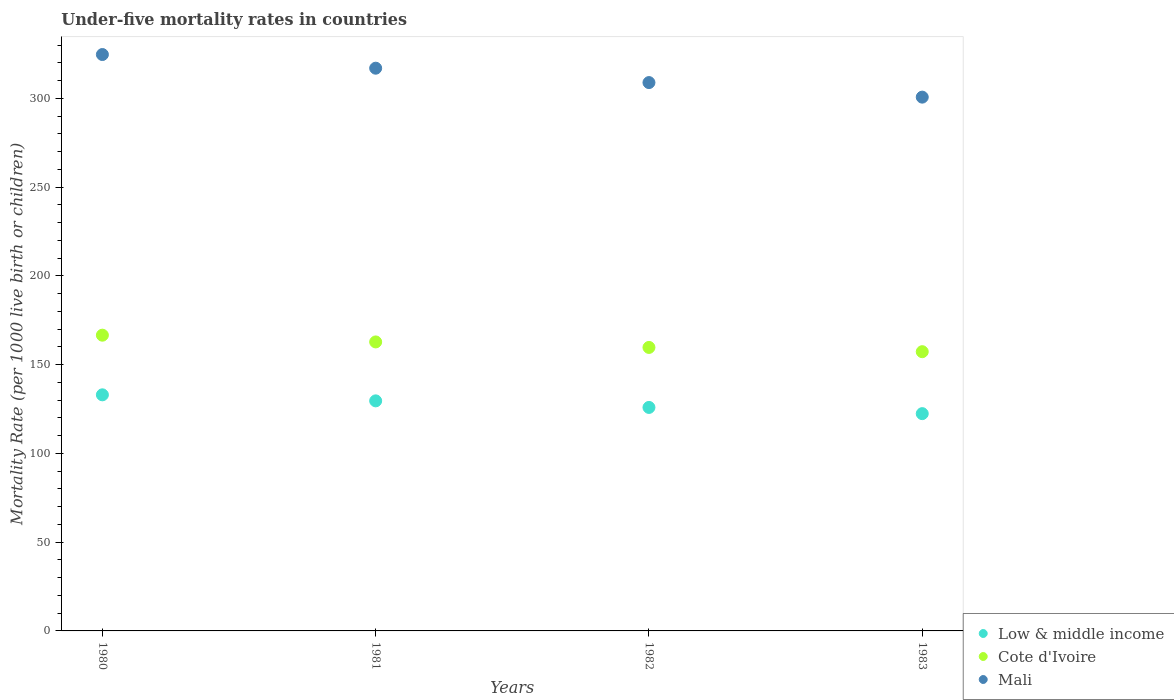How many different coloured dotlines are there?
Give a very brief answer. 3. Is the number of dotlines equal to the number of legend labels?
Offer a terse response. Yes. What is the under-five mortality rate in Mali in 1983?
Keep it short and to the point. 300.7. Across all years, what is the maximum under-five mortality rate in Mali?
Your answer should be very brief. 324.7. Across all years, what is the minimum under-five mortality rate in Low & middle income?
Your response must be concise. 122.4. What is the total under-five mortality rate in Cote d'Ivoire in the graph?
Offer a terse response. 646.4. What is the difference between the under-five mortality rate in Cote d'Ivoire in 1981 and that in 1982?
Offer a very short reply. 3.1. What is the difference between the under-five mortality rate in Mali in 1983 and the under-five mortality rate in Cote d'Ivoire in 1980?
Provide a short and direct response. 134.1. What is the average under-five mortality rate in Low & middle income per year?
Make the answer very short. 127.72. In the year 1981, what is the difference between the under-five mortality rate in Low & middle income and under-five mortality rate in Cote d'Ivoire?
Your answer should be very brief. -33.2. In how many years, is the under-five mortality rate in Cote d'Ivoire greater than 60?
Provide a short and direct response. 4. What is the ratio of the under-five mortality rate in Cote d'Ivoire in 1982 to that in 1983?
Your answer should be compact. 1.02. Is the under-five mortality rate in Mali in 1980 less than that in 1981?
Keep it short and to the point. No. What is the difference between the highest and the second highest under-five mortality rate in Mali?
Your answer should be very brief. 7.7. What is the difference between the highest and the lowest under-five mortality rate in Low & middle income?
Ensure brevity in your answer.  10.6. In how many years, is the under-five mortality rate in Low & middle income greater than the average under-five mortality rate in Low & middle income taken over all years?
Give a very brief answer. 2. Is it the case that in every year, the sum of the under-five mortality rate in Low & middle income and under-five mortality rate in Mali  is greater than the under-five mortality rate in Cote d'Ivoire?
Ensure brevity in your answer.  Yes. Is the under-five mortality rate in Low & middle income strictly less than the under-five mortality rate in Cote d'Ivoire over the years?
Offer a terse response. Yes. How many dotlines are there?
Your answer should be very brief. 3. What is the difference between two consecutive major ticks on the Y-axis?
Your answer should be very brief. 50. Are the values on the major ticks of Y-axis written in scientific E-notation?
Ensure brevity in your answer.  No. Does the graph contain any zero values?
Provide a succinct answer. No. How are the legend labels stacked?
Your response must be concise. Vertical. What is the title of the graph?
Keep it short and to the point. Under-five mortality rates in countries. What is the label or title of the Y-axis?
Your answer should be compact. Mortality Rate (per 1000 live birth or children). What is the Mortality Rate (per 1000 live birth or children) of Low & middle income in 1980?
Offer a terse response. 133. What is the Mortality Rate (per 1000 live birth or children) of Cote d'Ivoire in 1980?
Offer a very short reply. 166.6. What is the Mortality Rate (per 1000 live birth or children) of Mali in 1980?
Your answer should be very brief. 324.7. What is the Mortality Rate (per 1000 live birth or children) of Low & middle income in 1981?
Your response must be concise. 129.6. What is the Mortality Rate (per 1000 live birth or children) in Cote d'Ivoire in 1981?
Make the answer very short. 162.8. What is the Mortality Rate (per 1000 live birth or children) in Mali in 1981?
Keep it short and to the point. 317. What is the Mortality Rate (per 1000 live birth or children) in Low & middle income in 1982?
Give a very brief answer. 125.9. What is the Mortality Rate (per 1000 live birth or children) in Cote d'Ivoire in 1982?
Keep it short and to the point. 159.7. What is the Mortality Rate (per 1000 live birth or children) in Mali in 1982?
Your answer should be very brief. 308.9. What is the Mortality Rate (per 1000 live birth or children) of Low & middle income in 1983?
Offer a very short reply. 122.4. What is the Mortality Rate (per 1000 live birth or children) of Cote d'Ivoire in 1983?
Ensure brevity in your answer.  157.3. What is the Mortality Rate (per 1000 live birth or children) in Mali in 1983?
Offer a terse response. 300.7. Across all years, what is the maximum Mortality Rate (per 1000 live birth or children) of Low & middle income?
Keep it short and to the point. 133. Across all years, what is the maximum Mortality Rate (per 1000 live birth or children) of Cote d'Ivoire?
Offer a terse response. 166.6. Across all years, what is the maximum Mortality Rate (per 1000 live birth or children) in Mali?
Your answer should be compact. 324.7. Across all years, what is the minimum Mortality Rate (per 1000 live birth or children) in Low & middle income?
Offer a very short reply. 122.4. Across all years, what is the minimum Mortality Rate (per 1000 live birth or children) in Cote d'Ivoire?
Give a very brief answer. 157.3. Across all years, what is the minimum Mortality Rate (per 1000 live birth or children) of Mali?
Provide a succinct answer. 300.7. What is the total Mortality Rate (per 1000 live birth or children) of Low & middle income in the graph?
Give a very brief answer. 510.9. What is the total Mortality Rate (per 1000 live birth or children) in Cote d'Ivoire in the graph?
Your answer should be compact. 646.4. What is the total Mortality Rate (per 1000 live birth or children) in Mali in the graph?
Your answer should be compact. 1251.3. What is the difference between the Mortality Rate (per 1000 live birth or children) of Low & middle income in 1980 and that in 1981?
Offer a very short reply. 3.4. What is the difference between the Mortality Rate (per 1000 live birth or children) in Low & middle income in 1980 and that in 1982?
Keep it short and to the point. 7.1. What is the difference between the Mortality Rate (per 1000 live birth or children) of Cote d'Ivoire in 1980 and that in 1982?
Your answer should be compact. 6.9. What is the difference between the Mortality Rate (per 1000 live birth or children) of Mali in 1980 and that in 1982?
Ensure brevity in your answer.  15.8. What is the difference between the Mortality Rate (per 1000 live birth or children) in Cote d'Ivoire in 1980 and that in 1983?
Provide a succinct answer. 9.3. What is the difference between the Mortality Rate (per 1000 live birth or children) in Mali in 1980 and that in 1983?
Give a very brief answer. 24. What is the difference between the Mortality Rate (per 1000 live birth or children) in Cote d'Ivoire in 1981 and that in 1982?
Provide a succinct answer. 3.1. What is the difference between the Mortality Rate (per 1000 live birth or children) of Cote d'Ivoire in 1981 and that in 1983?
Ensure brevity in your answer.  5.5. What is the difference between the Mortality Rate (per 1000 live birth or children) in Low & middle income in 1982 and that in 1983?
Your response must be concise. 3.5. What is the difference between the Mortality Rate (per 1000 live birth or children) of Cote d'Ivoire in 1982 and that in 1983?
Keep it short and to the point. 2.4. What is the difference between the Mortality Rate (per 1000 live birth or children) of Low & middle income in 1980 and the Mortality Rate (per 1000 live birth or children) of Cote d'Ivoire in 1981?
Give a very brief answer. -29.8. What is the difference between the Mortality Rate (per 1000 live birth or children) in Low & middle income in 1980 and the Mortality Rate (per 1000 live birth or children) in Mali in 1981?
Provide a succinct answer. -184. What is the difference between the Mortality Rate (per 1000 live birth or children) in Cote d'Ivoire in 1980 and the Mortality Rate (per 1000 live birth or children) in Mali in 1981?
Provide a short and direct response. -150.4. What is the difference between the Mortality Rate (per 1000 live birth or children) of Low & middle income in 1980 and the Mortality Rate (per 1000 live birth or children) of Cote d'Ivoire in 1982?
Ensure brevity in your answer.  -26.7. What is the difference between the Mortality Rate (per 1000 live birth or children) of Low & middle income in 1980 and the Mortality Rate (per 1000 live birth or children) of Mali in 1982?
Offer a very short reply. -175.9. What is the difference between the Mortality Rate (per 1000 live birth or children) of Cote d'Ivoire in 1980 and the Mortality Rate (per 1000 live birth or children) of Mali in 1982?
Keep it short and to the point. -142.3. What is the difference between the Mortality Rate (per 1000 live birth or children) in Low & middle income in 1980 and the Mortality Rate (per 1000 live birth or children) in Cote d'Ivoire in 1983?
Your answer should be compact. -24.3. What is the difference between the Mortality Rate (per 1000 live birth or children) in Low & middle income in 1980 and the Mortality Rate (per 1000 live birth or children) in Mali in 1983?
Your response must be concise. -167.7. What is the difference between the Mortality Rate (per 1000 live birth or children) of Cote d'Ivoire in 1980 and the Mortality Rate (per 1000 live birth or children) of Mali in 1983?
Give a very brief answer. -134.1. What is the difference between the Mortality Rate (per 1000 live birth or children) of Low & middle income in 1981 and the Mortality Rate (per 1000 live birth or children) of Cote d'Ivoire in 1982?
Offer a very short reply. -30.1. What is the difference between the Mortality Rate (per 1000 live birth or children) in Low & middle income in 1981 and the Mortality Rate (per 1000 live birth or children) in Mali in 1982?
Offer a very short reply. -179.3. What is the difference between the Mortality Rate (per 1000 live birth or children) in Cote d'Ivoire in 1981 and the Mortality Rate (per 1000 live birth or children) in Mali in 1982?
Offer a very short reply. -146.1. What is the difference between the Mortality Rate (per 1000 live birth or children) in Low & middle income in 1981 and the Mortality Rate (per 1000 live birth or children) in Cote d'Ivoire in 1983?
Provide a succinct answer. -27.7. What is the difference between the Mortality Rate (per 1000 live birth or children) of Low & middle income in 1981 and the Mortality Rate (per 1000 live birth or children) of Mali in 1983?
Provide a short and direct response. -171.1. What is the difference between the Mortality Rate (per 1000 live birth or children) in Cote d'Ivoire in 1981 and the Mortality Rate (per 1000 live birth or children) in Mali in 1983?
Offer a terse response. -137.9. What is the difference between the Mortality Rate (per 1000 live birth or children) in Low & middle income in 1982 and the Mortality Rate (per 1000 live birth or children) in Cote d'Ivoire in 1983?
Make the answer very short. -31.4. What is the difference between the Mortality Rate (per 1000 live birth or children) in Low & middle income in 1982 and the Mortality Rate (per 1000 live birth or children) in Mali in 1983?
Your answer should be very brief. -174.8. What is the difference between the Mortality Rate (per 1000 live birth or children) in Cote d'Ivoire in 1982 and the Mortality Rate (per 1000 live birth or children) in Mali in 1983?
Give a very brief answer. -141. What is the average Mortality Rate (per 1000 live birth or children) of Low & middle income per year?
Keep it short and to the point. 127.72. What is the average Mortality Rate (per 1000 live birth or children) in Cote d'Ivoire per year?
Your answer should be compact. 161.6. What is the average Mortality Rate (per 1000 live birth or children) in Mali per year?
Give a very brief answer. 312.82. In the year 1980, what is the difference between the Mortality Rate (per 1000 live birth or children) of Low & middle income and Mortality Rate (per 1000 live birth or children) of Cote d'Ivoire?
Make the answer very short. -33.6. In the year 1980, what is the difference between the Mortality Rate (per 1000 live birth or children) of Low & middle income and Mortality Rate (per 1000 live birth or children) of Mali?
Provide a short and direct response. -191.7. In the year 1980, what is the difference between the Mortality Rate (per 1000 live birth or children) in Cote d'Ivoire and Mortality Rate (per 1000 live birth or children) in Mali?
Offer a very short reply. -158.1. In the year 1981, what is the difference between the Mortality Rate (per 1000 live birth or children) in Low & middle income and Mortality Rate (per 1000 live birth or children) in Cote d'Ivoire?
Offer a very short reply. -33.2. In the year 1981, what is the difference between the Mortality Rate (per 1000 live birth or children) of Low & middle income and Mortality Rate (per 1000 live birth or children) of Mali?
Keep it short and to the point. -187.4. In the year 1981, what is the difference between the Mortality Rate (per 1000 live birth or children) of Cote d'Ivoire and Mortality Rate (per 1000 live birth or children) of Mali?
Offer a very short reply. -154.2. In the year 1982, what is the difference between the Mortality Rate (per 1000 live birth or children) in Low & middle income and Mortality Rate (per 1000 live birth or children) in Cote d'Ivoire?
Give a very brief answer. -33.8. In the year 1982, what is the difference between the Mortality Rate (per 1000 live birth or children) in Low & middle income and Mortality Rate (per 1000 live birth or children) in Mali?
Your answer should be very brief. -183. In the year 1982, what is the difference between the Mortality Rate (per 1000 live birth or children) of Cote d'Ivoire and Mortality Rate (per 1000 live birth or children) of Mali?
Ensure brevity in your answer.  -149.2. In the year 1983, what is the difference between the Mortality Rate (per 1000 live birth or children) of Low & middle income and Mortality Rate (per 1000 live birth or children) of Cote d'Ivoire?
Provide a short and direct response. -34.9. In the year 1983, what is the difference between the Mortality Rate (per 1000 live birth or children) of Low & middle income and Mortality Rate (per 1000 live birth or children) of Mali?
Offer a very short reply. -178.3. In the year 1983, what is the difference between the Mortality Rate (per 1000 live birth or children) of Cote d'Ivoire and Mortality Rate (per 1000 live birth or children) of Mali?
Keep it short and to the point. -143.4. What is the ratio of the Mortality Rate (per 1000 live birth or children) of Low & middle income in 1980 to that in 1981?
Your response must be concise. 1.03. What is the ratio of the Mortality Rate (per 1000 live birth or children) in Cote d'Ivoire in 1980 to that in 1981?
Your response must be concise. 1.02. What is the ratio of the Mortality Rate (per 1000 live birth or children) of Mali in 1980 to that in 1981?
Your answer should be compact. 1.02. What is the ratio of the Mortality Rate (per 1000 live birth or children) of Low & middle income in 1980 to that in 1982?
Make the answer very short. 1.06. What is the ratio of the Mortality Rate (per 1000 live birth or children) in Cote d'Ivoire in 1980 to that in 1982?
Provide a succinct answer. 1.04. What is the ratio of the Mortality Rate (per 1000 live birth or children) in Mali in 1980 to that in 1982?
Your answer should be very brief. 1.05. What is the ratio of the Mortality Rate (per 1000 live birth or children) in Low & middle income in 1980 to that in 1983?
Provide a succinct answer. 1.09. What is the ratio of the Mortality Rate (per 1000 live birth or children) in Cote d'Ivoire in 1980 to that in 1983?
Offer a terse response. 1.06. What is the ratio of the Mortality Rate (per 1000 live birth or children) of Mali in 1980 to that in 1983?
Offer a very short reply. 1.08. What is the ratio of the Mortality Rate (per 1000 live birth or children) in Low & middle income in 1981 to that in 1982?
Offer a terse response. 1.03. What is the ratio of the Mortality Rate (per 1000 live birth or children) in Cote d'Ivoire in 1981 to that in 1982?
Your response must be concise. 1.02. What is the ratio of the Mortality Rate (per 1000 live birth or children) in Mali in 1981 to that in 1982?
Make the answer very short. 1.03. What is the ratio of the Mortality Rate (per 1000 live birth or children) of Low & middle income in 1981 to that in 1983?
Offer a very short reply. 1.06. What is the ratio of the Mortality Rate (per 1000 live birth or children) of Cote d'Ivoire in 1981 to that in 1983?
Your answer should be very brief. 1.03. What is the ratio of the Mortality Rate (per 1000 live birth or children) of Mali in 1981 to that in 1983?
Offer a very short reply. 1.05. What is the ratio of the Mortality Rate (per 1000 live birth or children) of Low & middle income in 1982 to that in 1983?
Your answer should be compact. 1.03. What is the ratio of the Mortality Rate (per 1000 live birth or children) of Cote d'Ivoire in 1982 to that in 1983?
Offer a very short reply. 1.02. What is the ratio of the Mortality Rate (per 1000 live birth or children) in Mali in 1982 to that in 1983?
Your answer should be very brief. 1.03. What is the difference between the highest and the lowest Mortality Rate (per 1000 live birth or children) of Mali?
Your answer should be very brief. 24. 